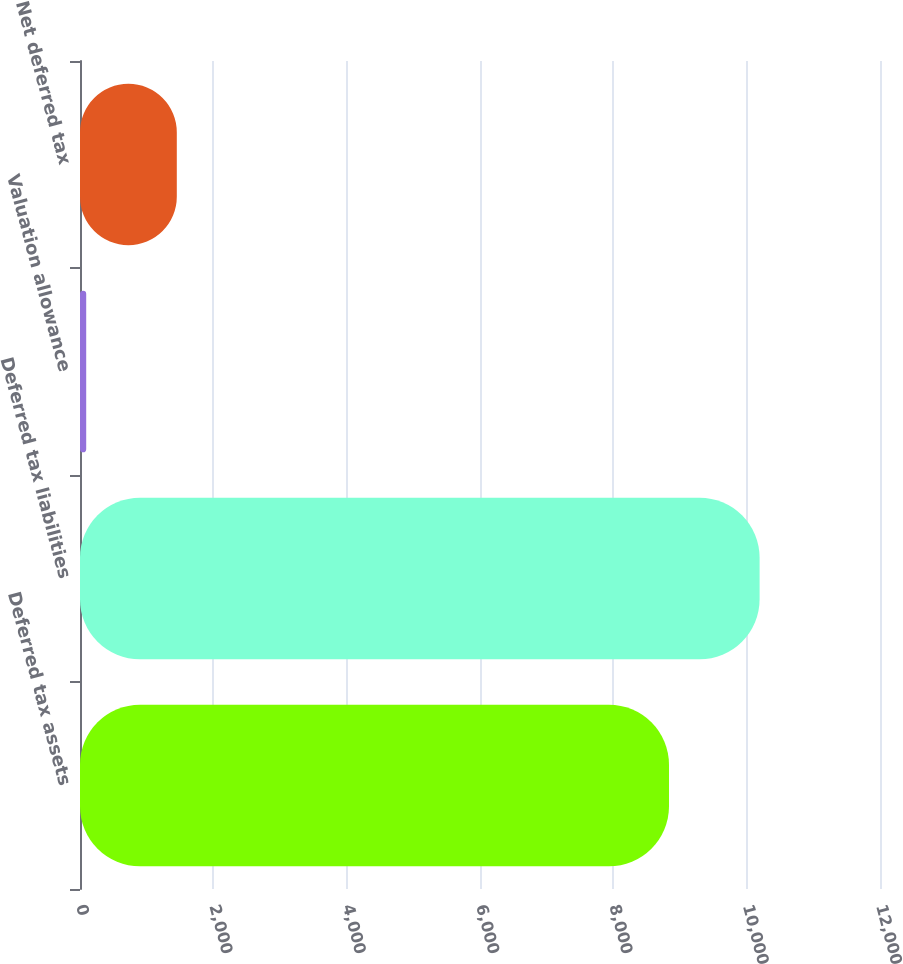Convert chart. <chart><loc_0><loc_0><loc_500><loc_500><bar_chart><fcel>Deferred tax assets<fcel>Deferred tax liabilities<fcel>Valuation allowance<fcel>Net deferred tax<nl><fcel>8835<fcel>10194<fcel>93<fcel>1452<nl></chart> 